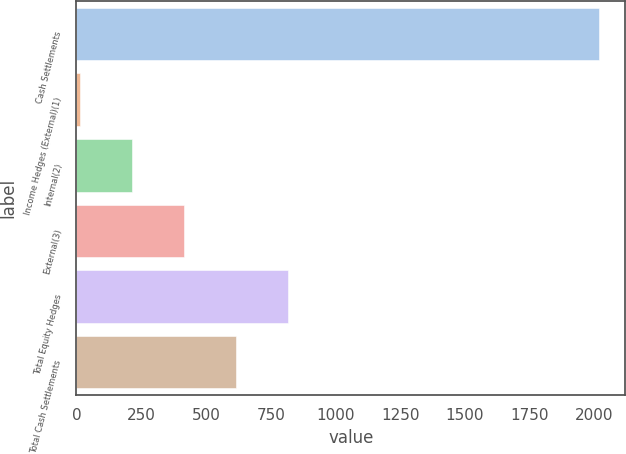<chart> <loc_0><loc_0><loc_500><loc_500><bar_chart><fcel>Cash Settlements<fcel>Income Hedges (External)(1)<fcel>Internal(2)<fcel>External(3)<fcel>Total Equity Hedges<fcel>Total Cash Settlements<nl><fcel>2018<fcel>13<fcel>213.5<fcel>414<fcel>815<fcel>614.5<nl></chart> 